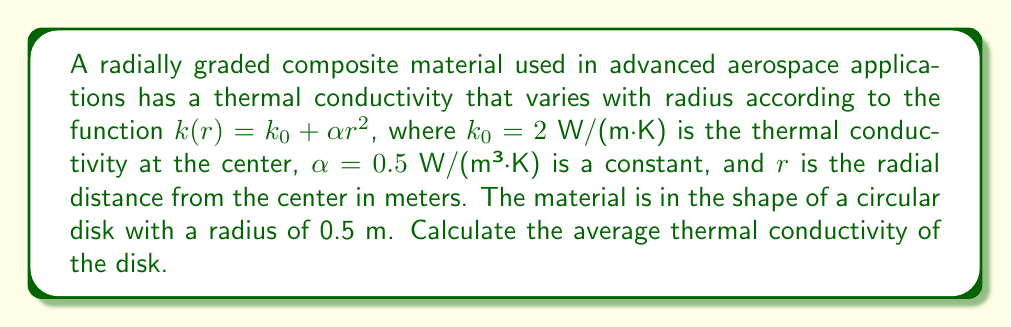Give your solution to this math problem. To solve this problem, we need to follow these steps:

1) The average thermal conductivity can be calculated by integrating the thermal conductivity function over the area of the disk and dividing by the total area.

2) In polar coordinates, the area element is given by $dA = r dr d\theta$.

3) The average thermal conductivity is given by:

   $$k_{avg} = \frac{\int_0^{2\pi} \int_0^R k(r) r dr d\theta}{\int_0^{2\pi} \int_0^R r dr d\theta}$$

   where $R = 0.5$ m is the radius of the disk.

4) Let's solve the numerator first:

   $$\int_0^{2\pi} \int_0^R k(r) r dr d\theta = \int_0^{2\pi} \int_0^R (k_0 + \alpha r^2) r dr d\theta$$
   
   $$= 2\pi \int_0^R (k_0 r + \alpha r^3) dr$$
   
   $$= 2\pi \left[\frac{k_0 r^2}{2} + \frac{\alpha r^4}{4}\right]_0^R$$
   
   $$= 2\pi \left(\frac{k_0 R^2}{2} + \frac{\alpha R^4}{4}\right)$$

5) Now the denominator:

   $$\int_0^{2\pi} \int_0^R r dr d\theta = 2\pi \int_0^R r dr = 2\pi \left[\frac{r^2}{2}\right]_0^R = \pi R^2$$

6) Dividing the numerator by the denominator:

   $$k_{avg} = \frac{2\pi (\frac{k_0 R^2}{2} + \frac{\alpha R^4}{4})}{\pi R^2} = k_0 + \frac{\alpha R^2}{2}$$

7) Substituting the values:

   $$k_{avg} = 2 + \frac{0.5 \cdot (0.5)^2}{2} = 2 + 0.0625 = 2.0625$$ W/(m·K)
Answer: The average thermal conductivity of the disk is 2.0625 W/(m·K). 